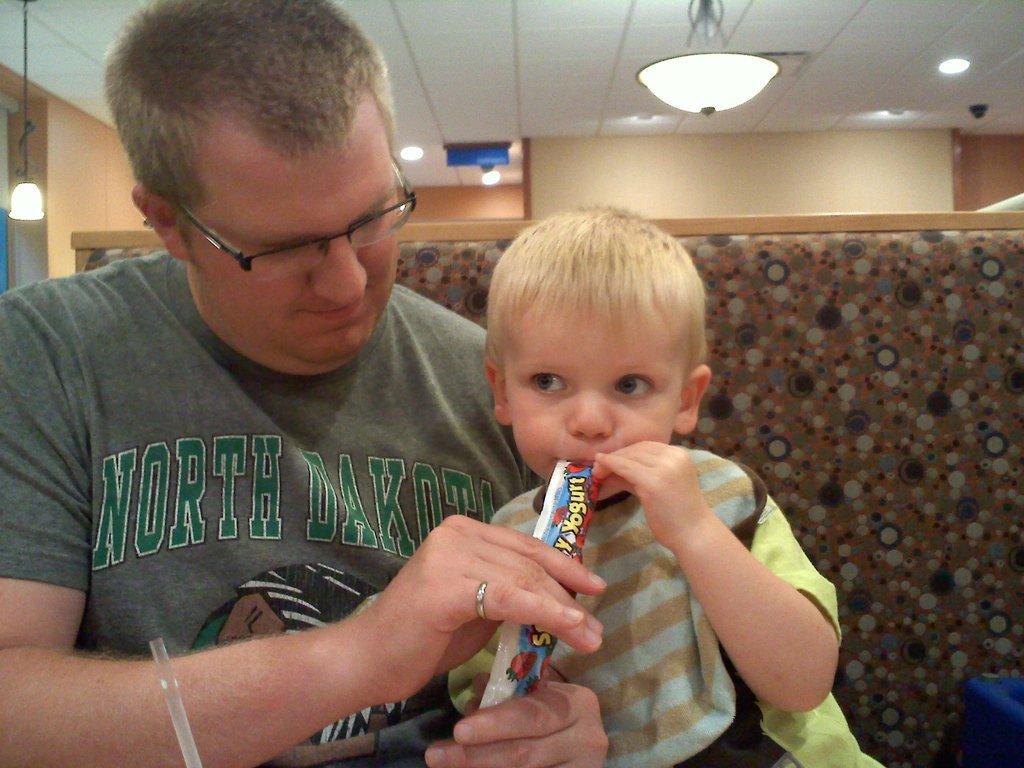In one or two sentences, can you explain what this image depicts? In this image we can see a man sitting and holding a baby. He is feeding him. In the background there is a wall. At the top we can see lights. 